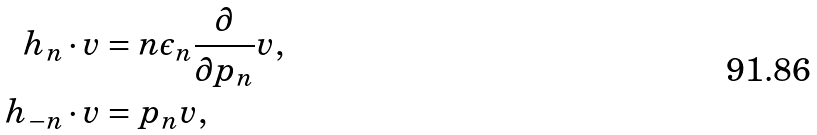<formula> <loc_0><loc_0><loc_500><loc_500>h _ { n } \cdot v & = n \epsilon _ { n } \frac { \partial } { \partial p _ { n } } v , \\ h _ { - n } \cdot v & = p _ { n } v ,</formula> 